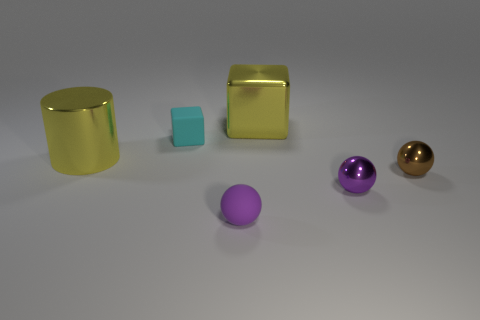Add 4 purple spheres. How many objects exist? 10 Subtract all cylinders. How many objects are left? 5 Add 5 tiny cyan matte blocks. How many tiny cyan matte blocks exist? 6 Subtract 1 cyan cubes. How many objects are left? 5 Subtract all tiny brown spheres. Subtract all purple spheres. How many objects are left? 3 Add 4 large objects. How many large objects are left? 6 